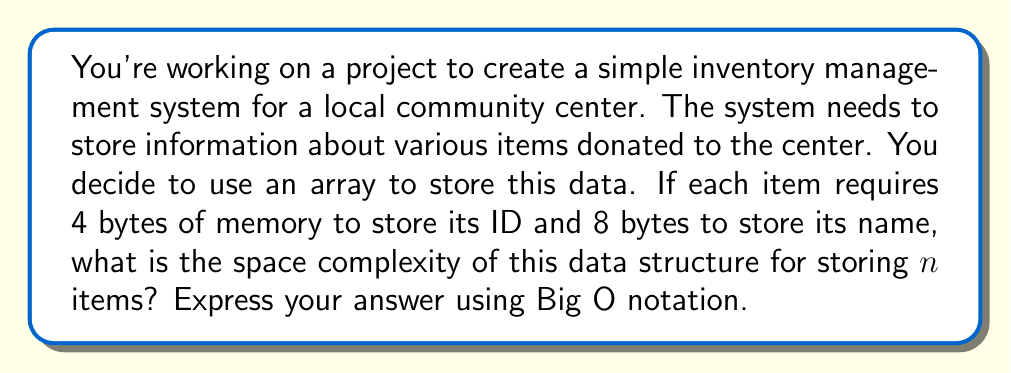Give your solution to this math problem. Let's approach this step-by-step:

1) First, let's consider the space required for a single item:
   - ID: 4 bytes
   - Name: 8 bytes
   Total per item: 4 + 8 = 12 bytes

2) Now, we're storing $n$ items, so we multiply this by $n$:
   Total space = 12 * $n$ bytes

3) In Big O notation, we're interested in the growth rate as $n$ increases. Constants are ignored, so whether it's 12$n$ or simply $n$, the growth rate is the same.

4) Therefore, the space complexity is $O(n)$.

This means that the space required grows linearly with the number of items. As you add more items to your inventory system, the memory needed will increase proportionally.

It's worth noting that this is a very efficient use of space. Each item takes up a fixed amount of memory, and there's no wasted space or overhead beyond what's needed to store the actual data.

In your context of working with limited resources at a community center, this efficiency is particularly important. It allows you to make the most of the available computer memory, potentially allowing you to store information about more donated items without needing to upgrade the hardware.
Answer: $O(n)$ 